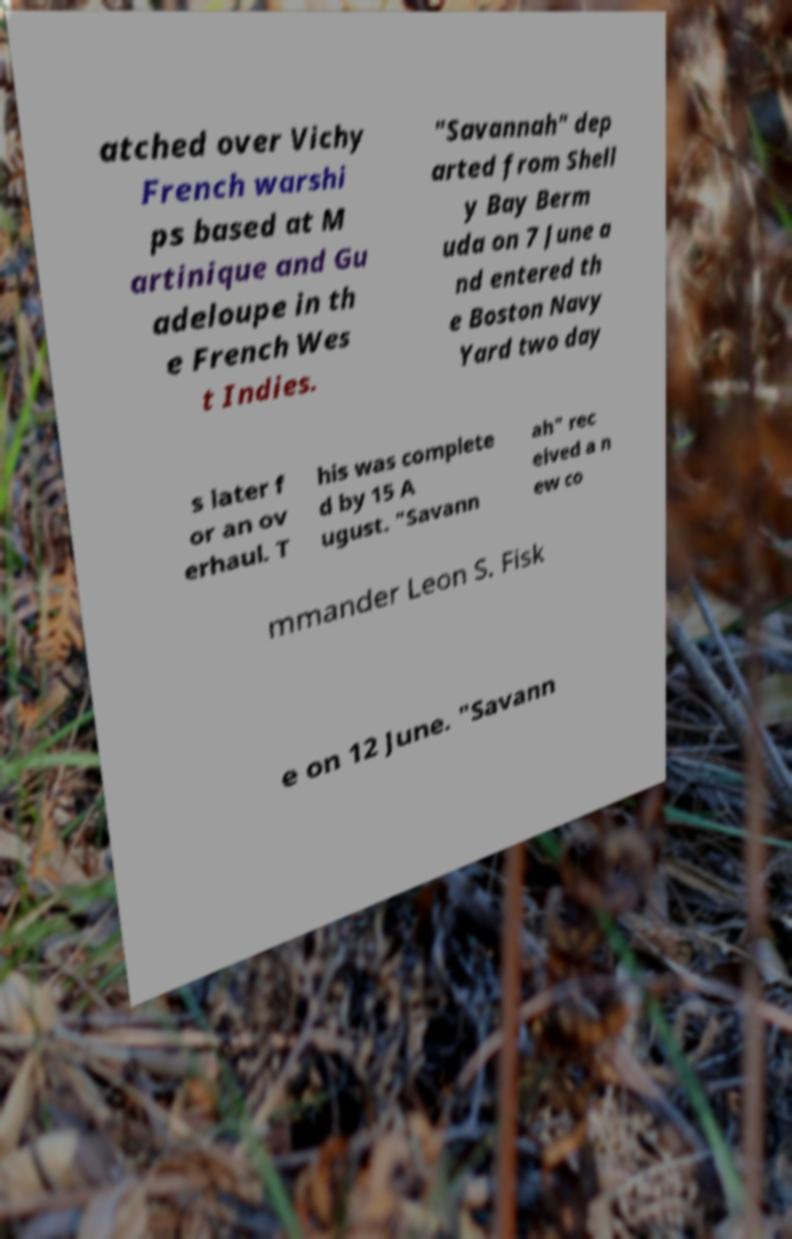Can you read and provide the text displayed in the image?This photo seems to have some interesting text. Can you extract and type it out for me? atched over Vichy French warshi ps based at M artinique and Gu adeloupe in th e French Wes t Indies. "Savannah" dep arted from Shell y Bay Berm uda on 7 June a nd entered th e Boston Navy Yard two day s later f or an ov erhaul. T his was complete d by 15 A ugust. "Savann ah" rec eived a n ew co mmander Leon S. Fisk e on 12 June. "Savann 